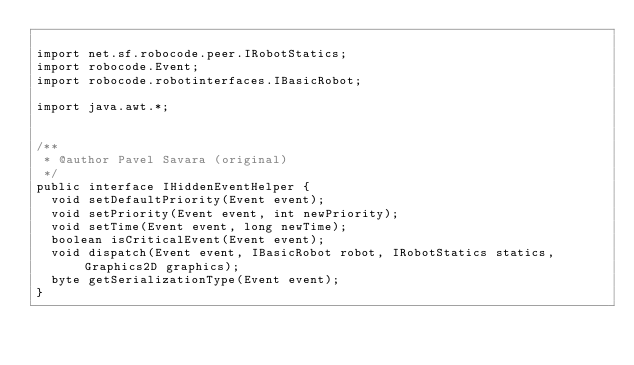Convert code to text. <code><loc_0><loc_0><loc_500><loc_500><_Java_>
import net.sf.robocode.peer.IRobotStatics;
import robocode.Event;
import robocode.robotinterfaces.IBasicRobot;

import java.awt.*;


/**
 * @author Pavel Savara (original)
 */
public interface IHiddenEventHelper {
	void setDefaultPriority(Event event);
	void setPriority(Event event, int newPriority);
	void setTime(Event event, long newTime);
	boolean isCriticalEvent(Event event);
	void dispatch(Event event, IBasicRobot robot, IRobotStatics statics, Graphics2D graphics);
	byte getSerializationType(Event event);
}
</code> 